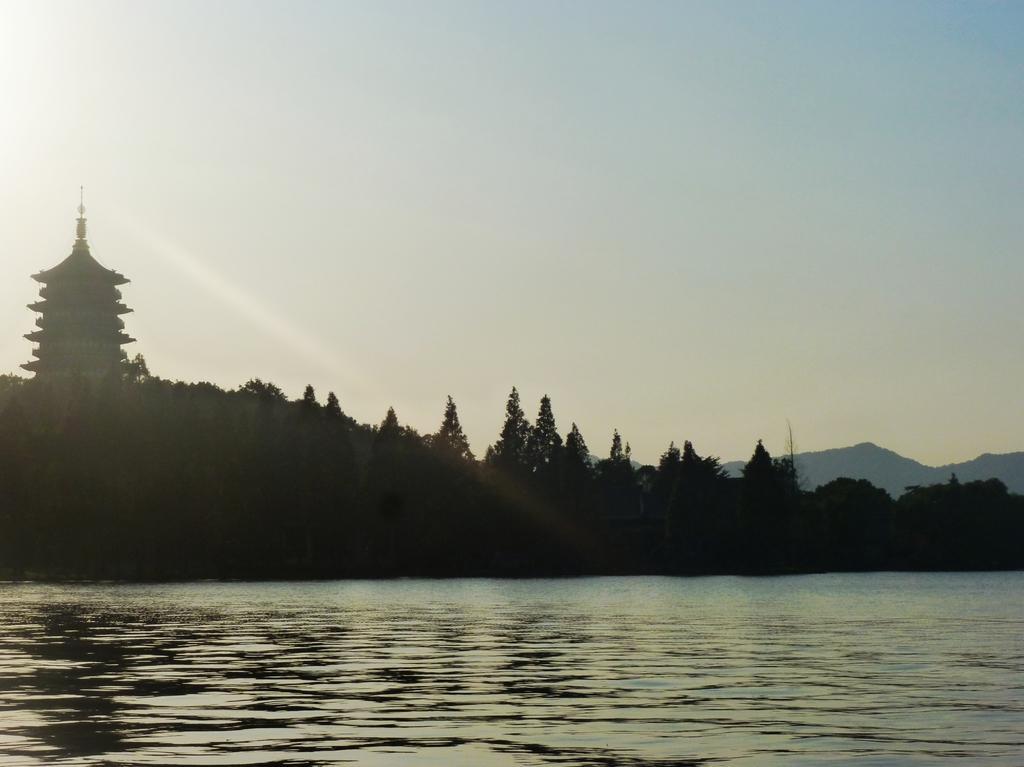In one or two sentences, can you explain what this image depicts? In this image to the bottom there is a river and in the background there are some trees and mountains, on the top of the image there is sky. 